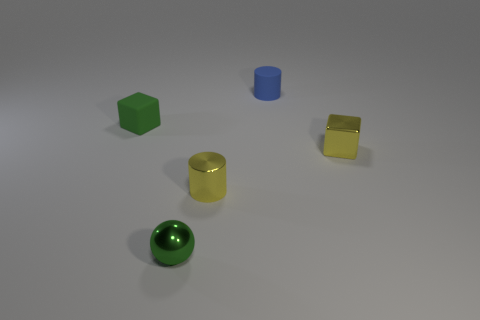Add 2 red rubber cubes. How many objects exist? 7 Subtract all blocks. How many objects are left? 3 Subtract all shiny objects. Subtract all small green spheres. How many objects are left? 1 Add 4 tiny yellow blocks. How many tiny yellow blocks are left? 5 Add 5 yellow metal things. How many yellow metal things exist? 7 Subtract 0 cyan spheres. How many objects are left? 5 